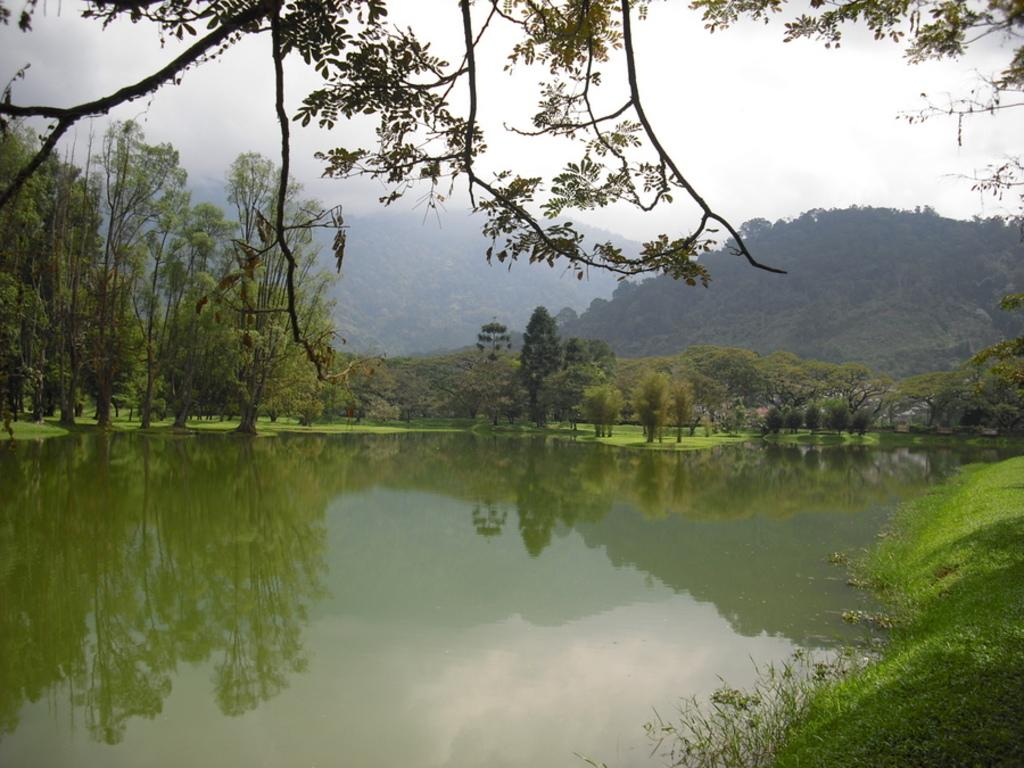What is visible in the foreground of the image? In the foreground of the image, there is water and grass. Can you describe the vegetation in the foreground? The vegetation in the foreground consists of grass. What can be seen in the background of the image? In the background of the image, there are trees, grassland, mountains, and fog on the top of the mountains. How many different types of vegetation can be seen in the image? There are two types of vegetation visible in the image: grass in the foreground and trees in the background. What type of wood can be seen in the image? There is no wood present in the image. How many seeds can be seen on the grass in the image? There are no seeds visible on the grass in the image. 